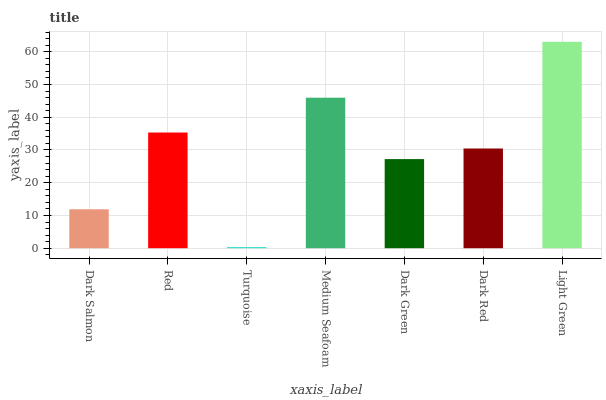Is Turquoise the minimum?
Answer yes or no. Yes. Is Light Green the maximum?
Answer yes or no. Yes. Is Red the minimum?
Answer yes or no. No. Is Red the maximum?
Answer yes or no. No. Is Red greater than Dark Salmon?
Answer yes or no. Yes. Is Dark Salmon less than Red?
Answer yes or no. Yes. Is Dark Salmon greater than Red?
Answer yes or no. No. Is Red less than Dark Salmon?
Answer yes or no. No. Is Dark Red the high median?
Answer yes or no. Yes. Is Dark Red the low median?
Answer yes or no. Yes. Is Turquoise the high median?
Answer yes or no. No. Is Red the low median?
Answer yes or no. No. 